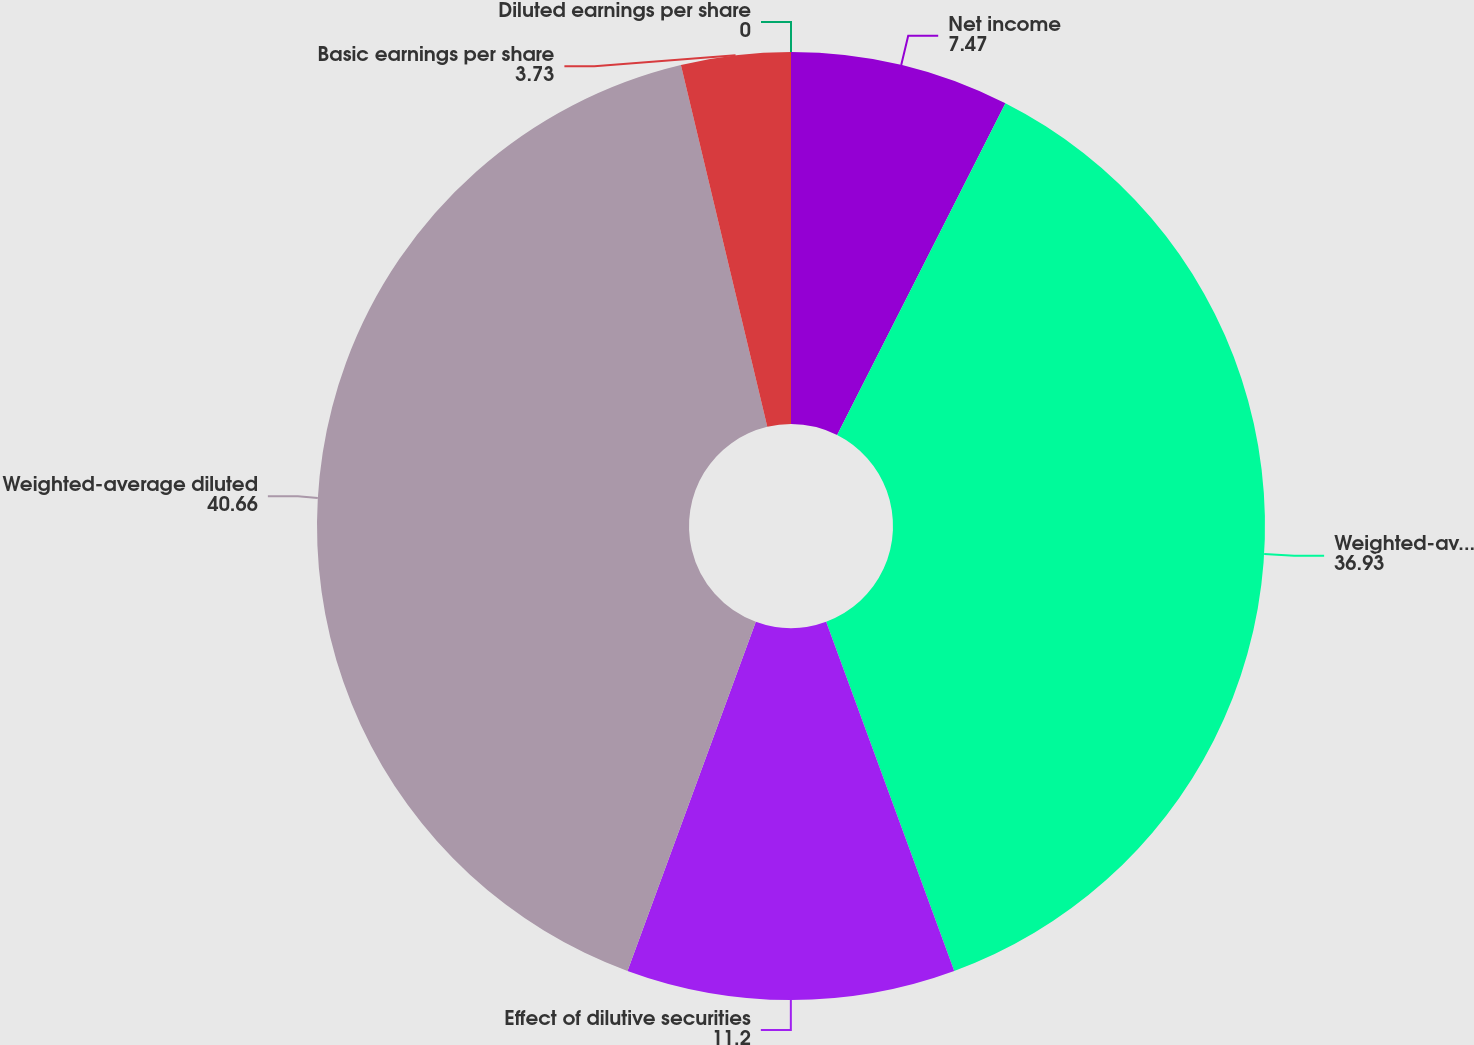Convert chart to OTSL. <chart><loc_0><loc_0><loc_500><loc_500><pie_chart><fcel>Net income<fcel>Weighted-average shares<fcel>Effect of dilutive securities<fcel>Weighted-average diluted<fcel>Basic earnings per share<fcel>Diluted earnings per share<nl><fcel>7.47%<fcel>36.93%<fcel>11.2%<fcel>40.66%<fcel>3.73%<fcel>0.0%<nl></chart> 